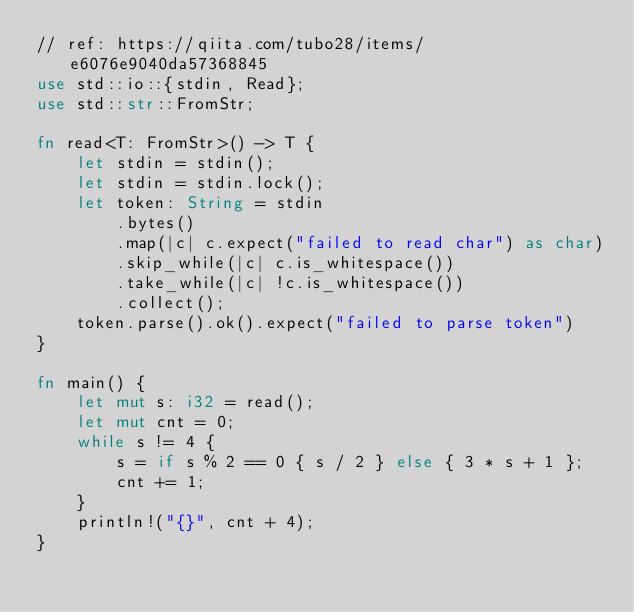<code> <loc_0><loc_0><loc_500><loc_500><_Rust_>// ref: https://qiita.com/tubo28/items/e6076e9040da57368845
use std::io::{stdin, Read};
use std::str::FromStr;

fn read<T: FromStr>() -> T {
    let stdin = stdin();
    let stdin = stdin.lock();
    let token: String = stdin
        .bytes()
        .map(|c| c.expect("failed to read char") as char)
        .skip_while(|c| c.is_whitespace())
        .take_while(|c| !c.is_whitespace())
        .collect();
    token.parse().ok().expect("failed to parse token")
}

fn main() {
    let mut s: i32 = read();
    let mut cnt = 0;
    while s != 4 {
        s = if s % 2 == 0 { s / 2 } else { 3 * s + 1 };
        cnt += 1;
    }
    println!("{}", cnt + 4);
}</code> 